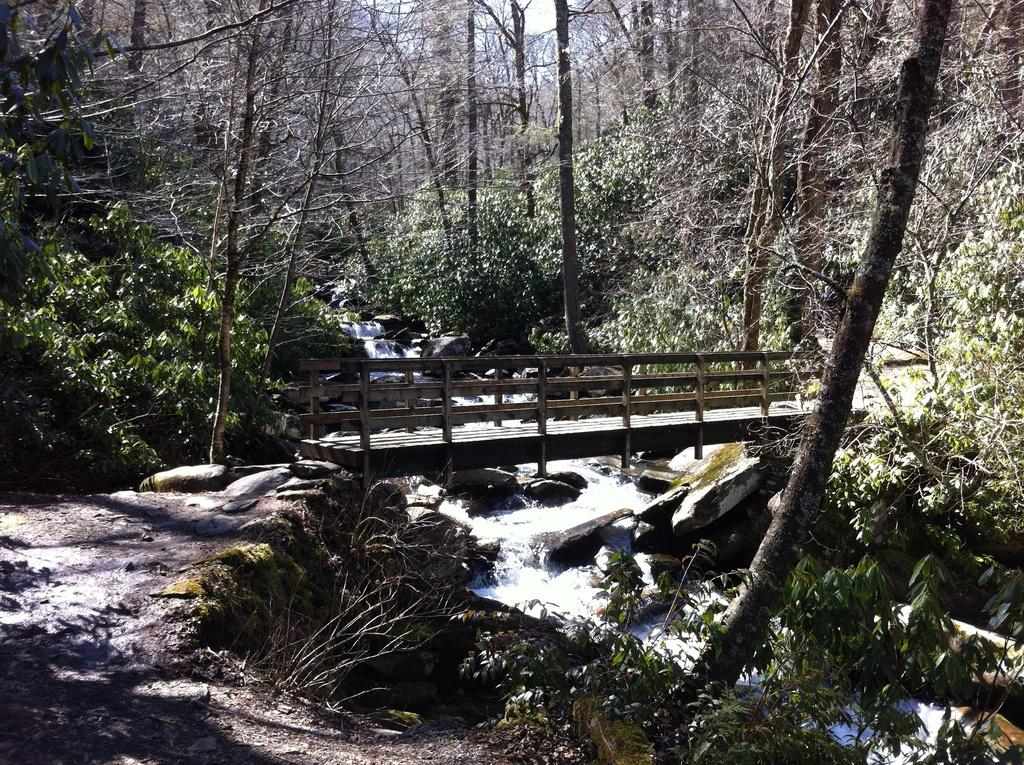What type of structure is present in the image? There is a wooden bridge in the image. What natural feature can be seen near the bridge? There is a river visible in the image. What type of vegetation is present in the image? There are trees in the image. What type of drink is being served on the wooden bridge in the image? There is no drink or serving activity present in the image; it features a wooden bridge, a river, and trees. 